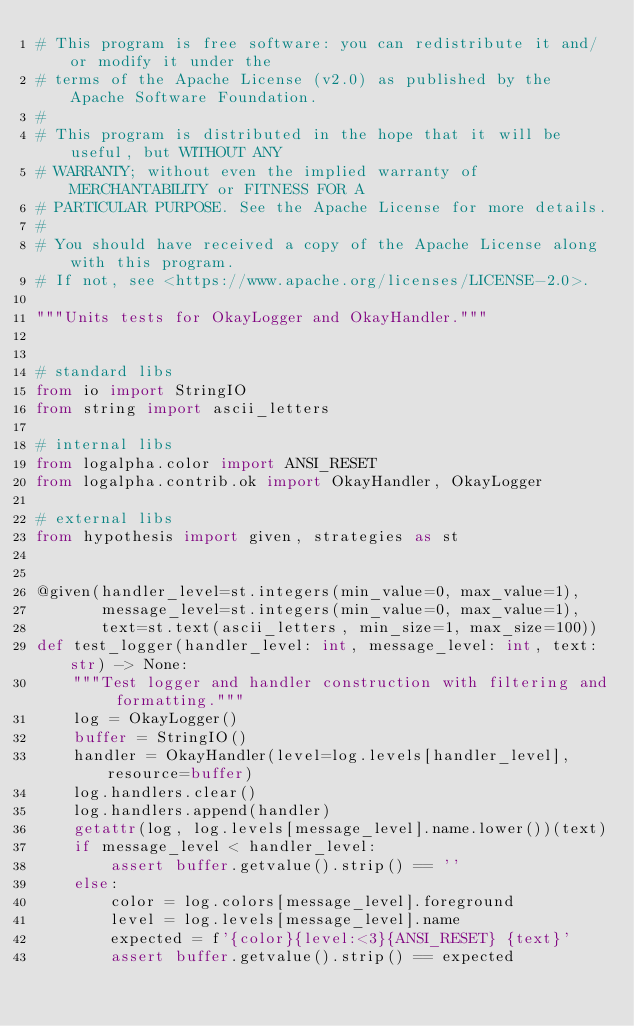Convert code to text. <code><loc_0><loc_0><loc_500><loc_500><_Python_># This program is free software: you can redistribute it and/or modify it under the
# terms of the Apache License (v2.0) as published by the Apache Software Foundation.
#
# This program is distributed in the hope that it will be useful, but WITHOUT ANY
# WARRANTY; without even the implied warranty of MERCHANTABILITY or FITNESS FOR A
# PARTICULAR PURPOSE. See the Apache License for more details.
#
# You should have received a copy of the Apache License along with this program.
# If not, see <https://www.apache.org/licenses/LICENSE-2.0>.

"""Units tests for OkayLogger and OkayHandler."""


# standard libs
from io import StringIO
from string import ascii_letters

# internal libs
from logalpha.color import ANSI_RESET
from logalpha.contrib.ok import OkayHandler, OkayLogger

# external libs
from hypothesis import given, strategies as st


@given(handler_level=st.integers(min_value=0, max_value=1),
       message_level=st.integers(min_value=0, max_value=1),
       text=st.text(ascii_letters, min_size=1, max_size=100))
def test_logger(handler_level: int, message_level: int, text: str) -> None:
    """Test logger and handler construction with filtering and formatting."""
    log = OkayLogger()
    buffer = StringIO()
    handler = OkayHandler(level=log.levels[handler_level], resource=buffer)
    log.handlers.clear()
    log.handlers.append(handler)
    getattr(log, log.levels[message_level].name.lower())(text)
    if message_level < handler_level:
        assert buffer.getvalue().strip() == ''
    else:
        color = log.colors[message_level].foreground
        level = log.levels[message_level].name
        expected = f'{color}{level:<3}{ANSI_RESET} {text}'
        assert buffer.getvalue().strip() == expected
</code> 